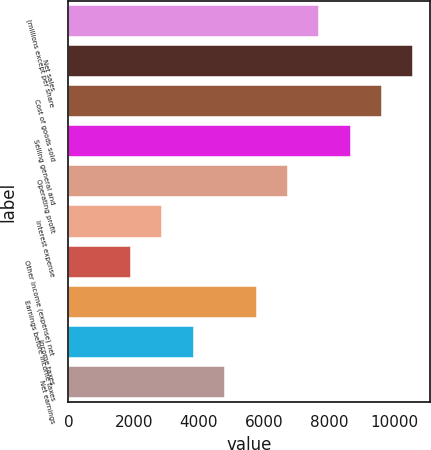Convert chart to OTSL. <chart><loc_0><loc_0><loc_500><loc_500><bar_chart><fcel>(millions except per share<fcel>Net sales<fcel>Cost of goods sold<fcel>Selling general and<fcel>Operating profit<fcel>Interest expense<fcel>Other income (expense) net<fcel>Earnings before income taxes<fcel>Income taxes<fcel>Net earnings<nl><fcel>7691.58<fcel>10575.1<fcel>9613.94<fcel>8652.76<fcel>6730.4<fcel>2885.68<fcel>1924.5<fcel>5769.22<fcel>3846.86<fcel>4808.04<nl></chart> 